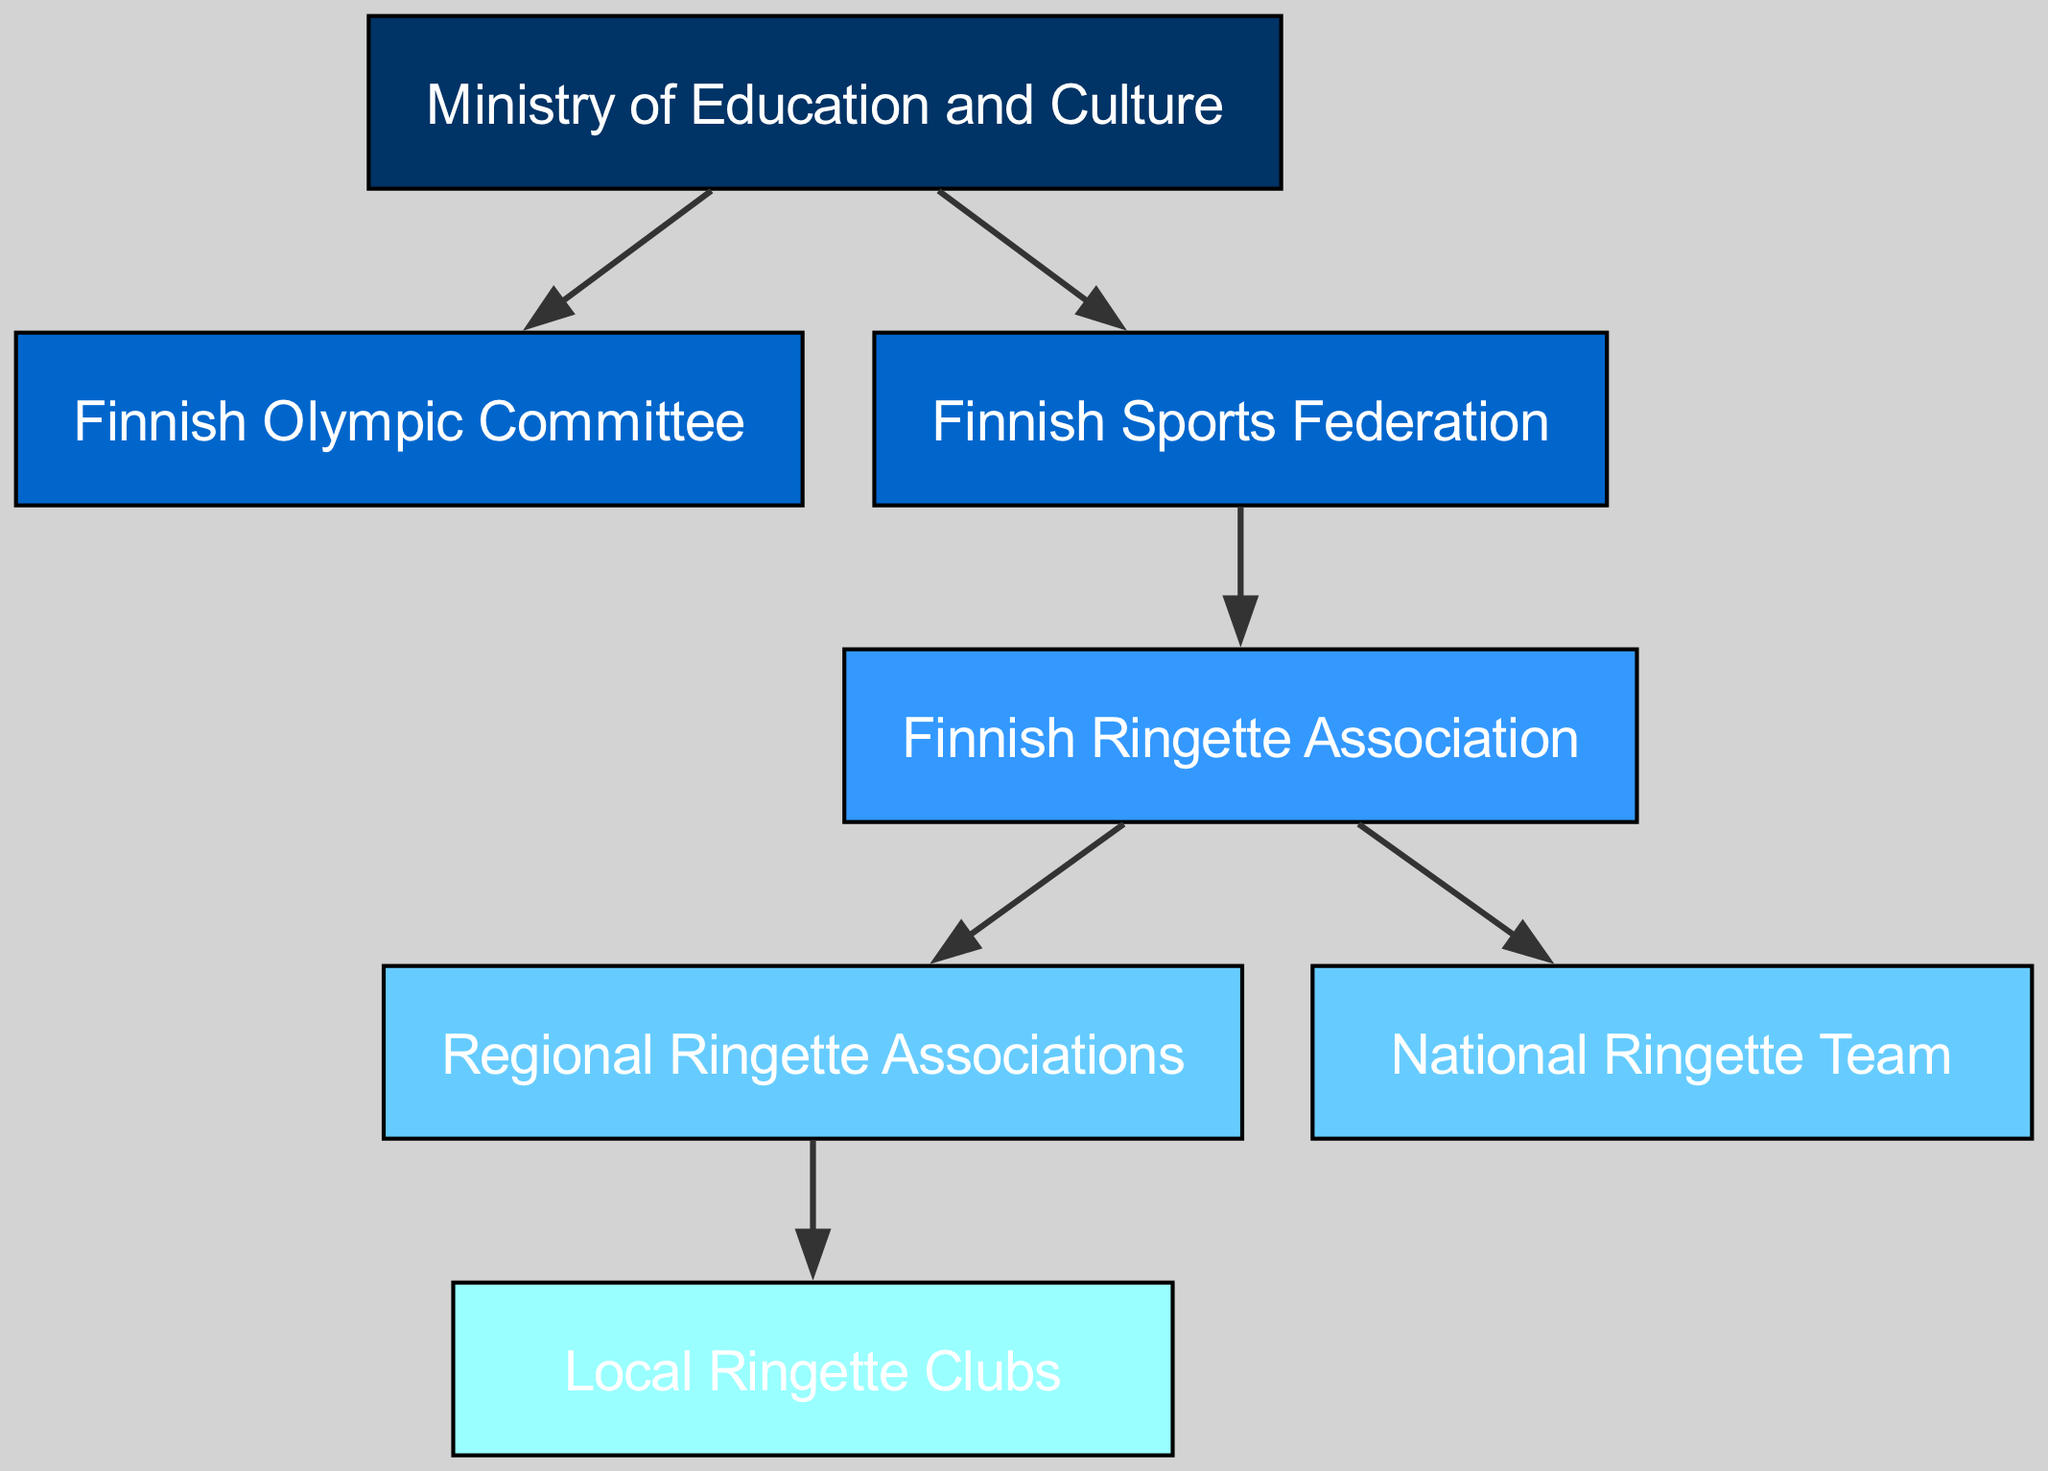What is the highest level in the Finnish sports administration system? The highest level in the diagram is represented by the node "Ministry of Education and Culture," which is at level 1. This can be determined by observing the hierarchy from top to bottom.
Answer: Ministry of Education and Culture How many nodes are in the diagram? By counting each of the unique entities listed in the nodes section, we find there are 7 nodes total, which include all levels of the administration system.
Answer: 7 Which entity is connected directly to the Finnish Olympic Committee? The Finnish Olympic Committee is directly connected to the Ministry of Education and Culture above it, as seen in the directed edges. This connection shows that it's part of the structure right under the ministry.
Answer: Ministry of Education and Culture What is the relationship between the Finnish Ringette Association and Local Ringette Clubs? The Finnish Ringette Association has a direct subordinating relationship to the Regional Ringette Associations and the National Ringette Team, while the Local Ringette Clubs are subordinate to the Regional Organizations, meaning they are part of the same hierarchical structure focused on ringette.
Answer: Regional Ringette Associations How many levels are there in the Finnish sports administration system? The levels in the diagram are numbered from 1 to 5. Counting from the top node down, we can directly observe that there are 5 distinct levels in the structure.
Answer: 5 Who has oversight over the Finnish Ringette Association? The Finnish Sports Federation has oversight over the Finnish Ringette Association. This can be inferred from the connecting edge leading directly from the Finnish Sports Federation node to the Finnish Ringette Association node.
Answer: Finnish Sports Federation Which node is the immediate subordinate of the Finnish Ringette Association? The immediate subordinate of the Finnish Ringette Association is the Regional Ringette Associations, as it is directly connected below in the hierarchy. This is evident by the directed edge between these two nodes.
Answer: Regional Ringette Associations What is the total number of edges in the diagram? By counting the connections between nodes (or edges), we find that there are 6 edges present in the diagram, representing the relationships between different administrative entities.
Answer: 6 